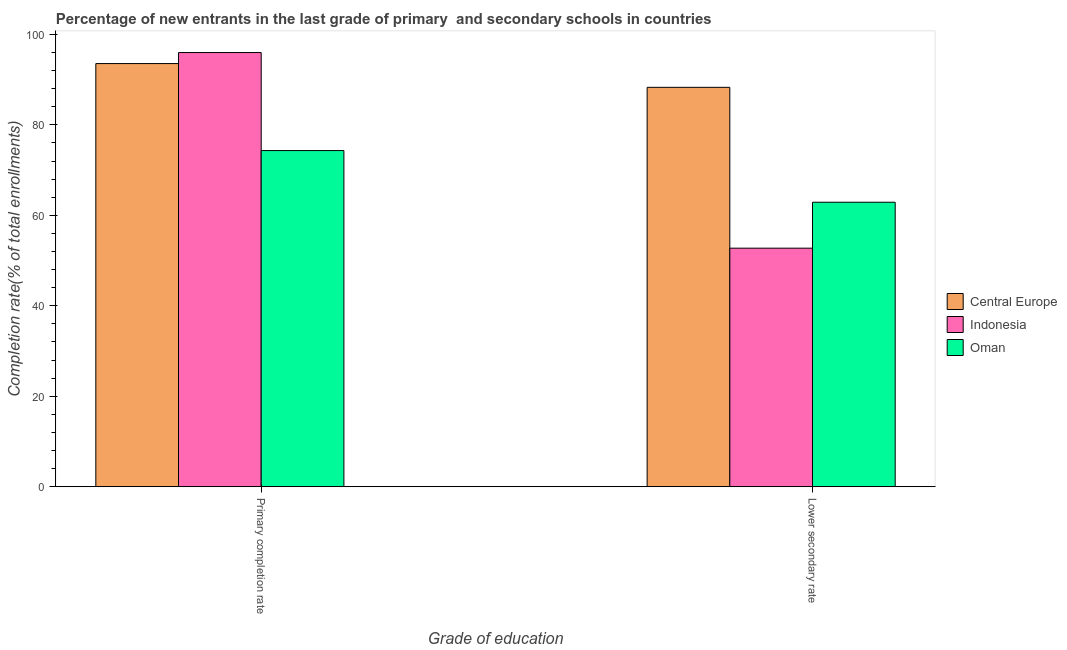How many different coloured bars are there?
Offer a very short reply. 3. How many groups of bars are there?
Your response must be concise. 2. Are the number of bars on each tick of the X-axis equal?
Your response must be concise. Yes. What is the label of the 2nd group of bars from the left?
Offer a terse response. Lower secondary rate. What is the completion rate in primary schools in Oman?
Your answer should be compact. 74.31. Across all countries, what is the maximum completion rate in secondary schools?
Your answer should be very brief. 88.29. Across all countries, what is the minimum completion rate in primary schools?
Offer a very short reply. 74.31. In which country was the completion rate in secondary schools maximum?
Offer a very short reply. Central Europe. In which country was the completion rate in primary schools minimum?
Keep it short and to the point. Oman. What is the total completion rate in secondary schools in the graph?
Provide a short and direct response. 203.91. What is the difference between the completion rate in secondary schools in Oman and that in Indonesia?
Your answer should be very brief. 10.16. What is the difference between the completion rate in primary schools in Indonesia and the completion rate in secondary schools in Central Europe?
Provide a short and direct response. 7.69. What is the average completion rate in primary schools per country?
Your answer should be compact. 87.94. What is the difference between the completion rate in primary schools and completion rate in secondary schools in Indonesia?
Offer a terse response. 43.25. In how many countries, is the completion rate in primary schools greater than 12 %?
Make the answer very short. 3. What is the ratio of the completion rate in primary schools in Indonesia to that in Oman?
Your answer should be very brief. 1.29. In how many countries, is the completion rate in primary schools greater than the average completion rate in primary schools taken over all countries?
Your response must be concise. 2. What does the 3rd bar from the left in Lower secondary rate represents?
Provide a short and direct response. Oman. How many countries are there in the graph?
Keep it short and to the point. 3. What is the difference between two consecutive major ticks on the Y-axis?
Provide a succinct answer. 20. Does the graph contain any zero values?
Provide a short and direct response. No. Where does the legend appear in the graph?
Your response must be concise. Center right. How are the legend labels stacked?
Provide a short and direct response. Vertical. What is the title of the graph?
Ensure brevity in your answer.  Percentage of new entrants in the last grade of primary  and secondary schools in countries. What is the label or title of the X-axis?
Keep it short and to the point. Grade of education. What is the label or title of the Y-axis?
Offer a terse response. Completion rate(% of total enrollments). What is the Completion rate(% of total enrollments) in Central Europe in Primary completion rate?
Keep it short and to the point. 93.54. What is the Completion rate(% of total enrollments) in Indonesia in Primary completion rate?
Offer a terse response. 95.98. What is the Completion rate(% of total enrollments) of Oman in Primary completion rate?
Provide a short and direct response. 74.31. What is the Completion rate(% of total enrollments) of Central Europe in Lower secondary rate?
Provide a succinct answer. 88.29. What is the Completion rate(% of total enrollments) in Indonesia in Lower secondary rate?
Offer a terse response. 52.73. What is the Completion rate(% of total enrollments) of Oman in Lower secondary rate?
Provide a succinct answer. 62.89. Across all Grade of education, what is the maximum Completion rate(% of total enrollments) of Central Europe?
Keep it short and to the point. 93.54. Across all Grade of education, what is the maximum Completion rate(% of total enrollments) of Indonesia?
Keep it short and to the point. 95.98. Across all Grade of education, what is the maximum Completion rate(% of total enrollments) of Oman?
Your answer should be compact. 74.31. Across all Grade of education, what is the minimum Completion rate(% of total enrollments) in Central Europe?
Your answer should be compact. 88.29. Across all Grade of education, what is the minimum Completion rate(% of total enrollments) of Indonesia?
Your answer should be very brief. 52.73. Across all Grade of education, what is the minimum Completion rate(% of total enrollments) of Oman?
Make the answer very short. 62.89. What is the total Completion rate(% of total enrollments) in Central Europe in the graph?
Make the answer very short. 181.83. What is the total Completion rate(% of total enrollments) of Indonesia in the graph?
Make the answer very short. 148.72. What is the total Completion rate(% of total enrollments) of Oman in the graph?
Your response must be concise. 137.2. What is the difference between the Completion rate(% of total enrollments) in Central Europe in Primary completion rate and that in Lower secondary rate?
Your answer should be very brief. 5.25. What is the difference between the Completion rate(% of total enrollments) of Indonesia in Primary completion rate and that in Lower secondary rate?
Ensure brevity in your answer.  43.25. What is the difference between the Completion rate(% of total enrollments) of Oman in Primary completion rate and that in Lower secondary rate?
Provide a short and direct response. 11.42. What is the difference between the Completion rate(% of total enrollments) of Central Europe in Primary completion rate and the Completion rate(% of total enrollments) of Indonesia in Lower secondary rate?
Keep it short and to the point. 40.81. What is the difference between the Completion rate(% of total enrollments) in Central Europe in Primary completion rate and the Completion rate(% of total enrollments) in Oman in Lower secondary rate?
Your answer should be compact. 30.66. What is the difference between the Completion rate(% of total enrollments) in Indonesia in Primary completion rate and the Completion rate(% of total enrollments) in Oman in Lower secondary rate?
Keep it short and to the point. 33.09. What is the average Completion rate(% of total enrollments) in Central Europe per Grade of education?
Offer a terse response. 90.92. What is the average Completion rate(% of total enrollments) of Indonesia per Grade of education?
Your answer should be compact. 74.36. What is the average Completion rate(% of total enrollments) of Oman per Grade of education?
Offer a terse response. 68.6. What is the difference between the Completion rate(% of total enrollments) of Central Europe and Completion rate(% of total enrollments) of Indonesia in Primary completion rate?
Your answer should be very brief. -2.44. What is the difference between the Completion rate(% of total enrollments) of Central Europe and Completion rate(% of total enrollments) of Oman in Primary completion rate?
Provide a short and direct response. 19.23. What is the difference between the Completion rate(% of total enrollments) of Indonesia and Completion rate(% of total enrollments) of Oman in Primary completion rate?
Provide a succinct answer. 21.67. What is the difference between the Completion rate(% of total enrollments) of Central Europe and Completion rate(% of total enrollments) of Indonesia in Lower secondary rate?
Your answer should be compact. 35.56. What is the difference between the Completion rate(% of total enrollments) in Central Europe and Completion rate(% of total enrollments) in Oman in Lower secondary rate?
Offer a terse response. 25.4. What is the difference between the Completion rate(% of total enrollments) in Indonesia and Completion rate(% of total enrollments) in Oman in Lower secondary rate?
Offer a terse response. -10.16. What is the ratio of the Completion rate(% of total enrollments) of Central Europe in Primary completion rate to that in Lower secondary rate?
Make the answer very short. 1.06. What is the ratio of the Completion rate(% of total enrollments) of Indonesia in Primary completion rate to that in Lower secondary rate?
Provide a short and direct response. 1.82. What is the ratio of the Completion rate(% of total enrollments) of Oman in Primary completion rate to that in Lower secondary rate?
Provide a short and direct response. 1.18. What is the difference between the highest and the second highest Completion rate(% of total enrollments) of Central Europe?
Make the answer very short. 5.25. What is the difference between the highest and the second highest Completion rate(% of total enrollments) of Indonesia?
Ensure brevity in your answer.  43.25. What is the difference between the highest and the second highest Completion rate(% of total enrollments) in Oman?
Make the answer very short. 11.42. What is the difference between the highest and the lowest Completion rate(% of total enrollments) in Central Europe?
Your answer should be compact. 5.25. What is the difference between the highest and the lowest Completion rate(% of total enrollments) in Indonesia?
Give a very brief answer. 43.25. What is the difference between the highest and the lowest Completion rate(% of total enrollments) of Oman?
Keep it short and to the point. 11.42. 